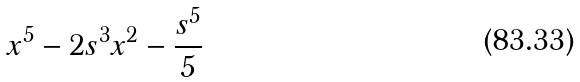Convert formula to latex. <formula><loc_0><loc_0><loc_500><loc_500>x ^ { 5 } - 2 s ^ { 3 } x ^ { 2 } - { \frac { s ^ { 5 } } { 5 } }</formula> 